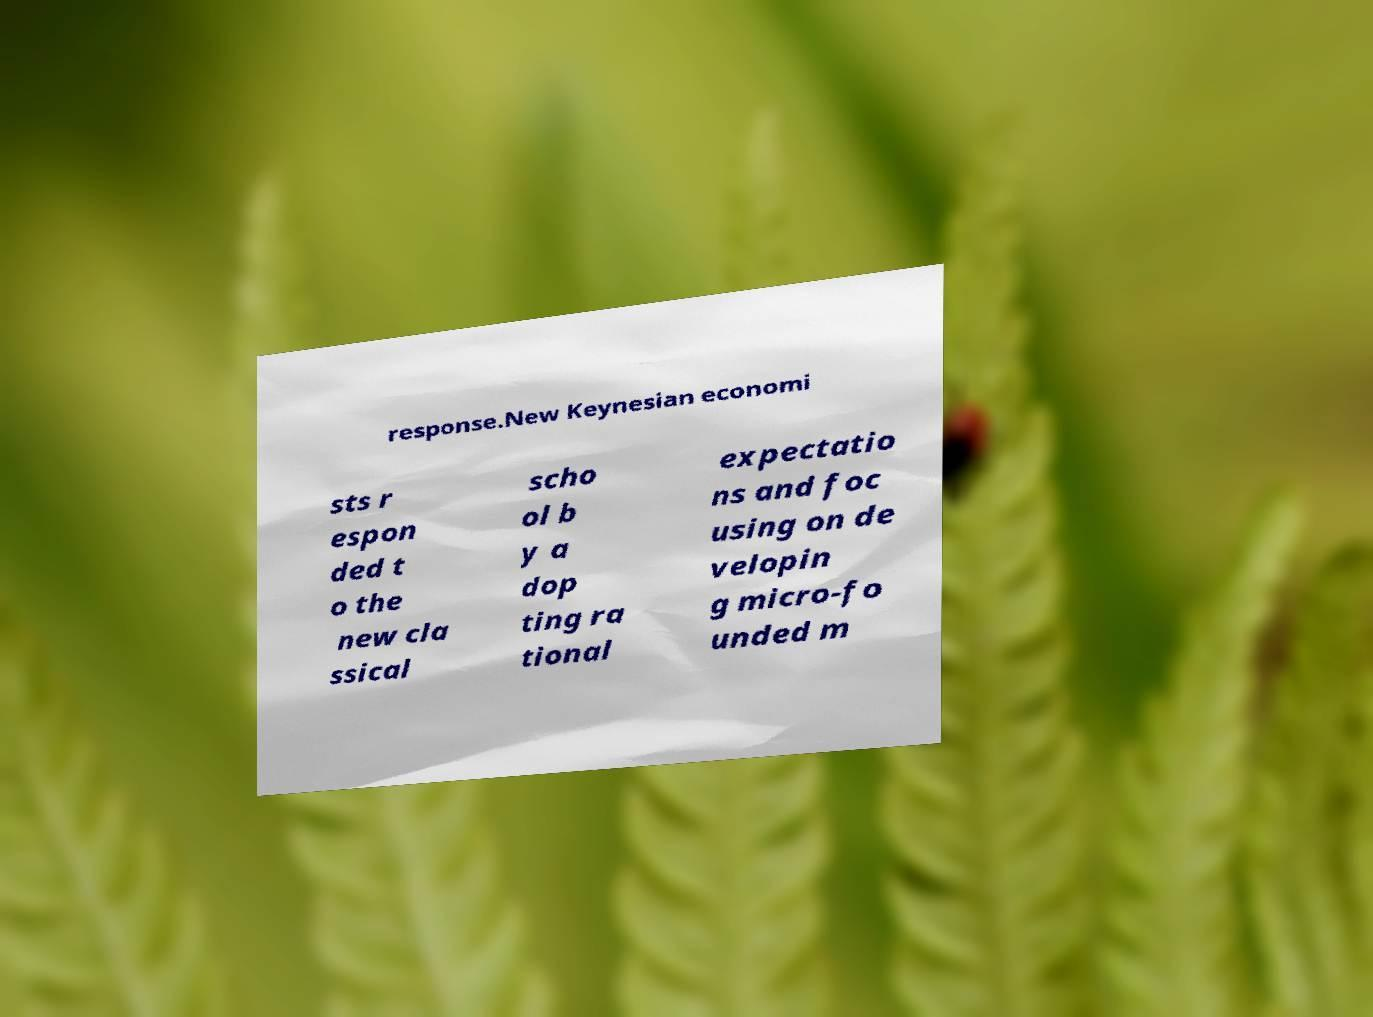For documentation purposes, I need the text within this image transcribed. Could you provide that? response.New Keynesian economi sts r espon ded t o the new cla ssical scho ol b y a dop ting ra tional expectatio ns and foc using on de velopin g micro-fo unded m 